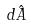Convert formula to latex. <formula><loc_0><loc_0><loc_500><loc_500>d \hat { A }</formula> 